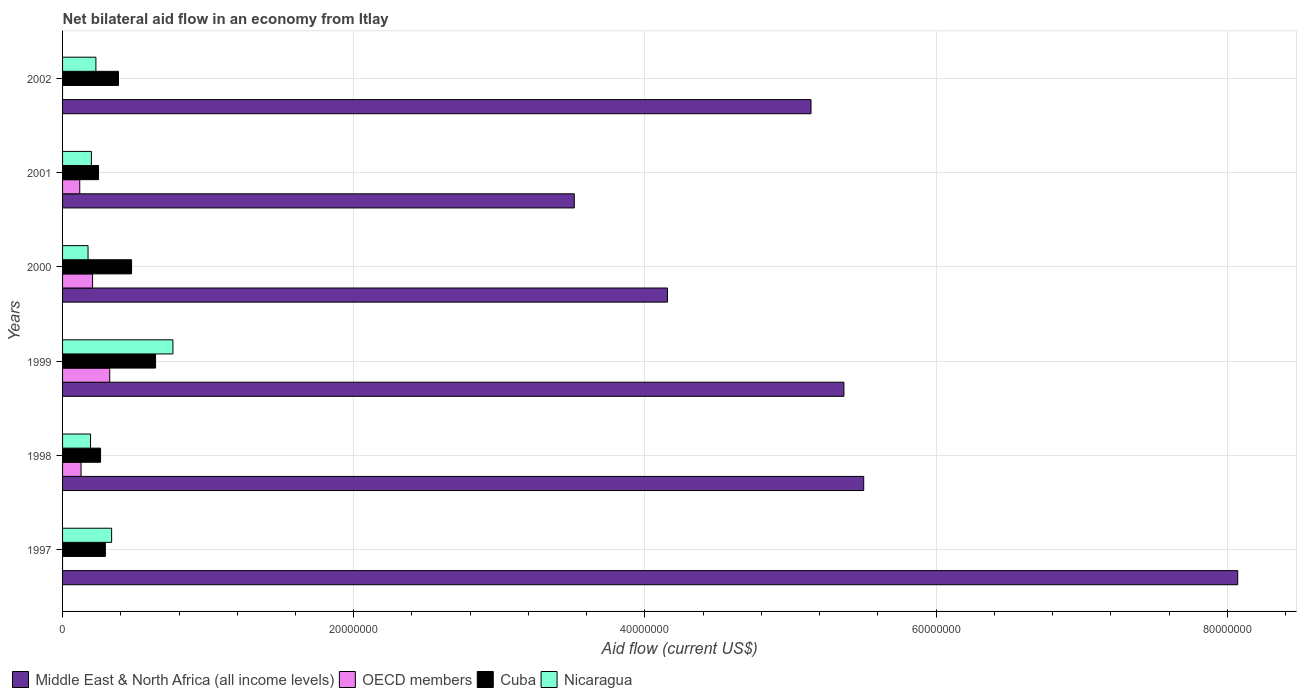How many different coloured bars are there?
Keep it short and to the point. 4. How many groups of bars are there?
Offer a terse response. 6. Are the number of bars per tick equal to the number of legend labels?
Provide a succinct answer. No. How many bars are there on the 2nd tick from the top?
Offer a very short reply. 4. How many bars are there on the 3rd tick from the bottom?
Keep it short and to the point. 4. What is the label of the 5th group of bars from the top?
Offer a terse response. 1998. In how many cases, is the number of bars for a given year not equal to the number of legend labels?
Offer a very short reply. 2. What is the net bilateral aid flow in Cuba in 2000?
Make the answer very short. 4.74e+06. Across all years, what is the maximum net bilateral aid flow in Nicaragua?
Provide a short and direct response. 7.58e+06. Across all years, what is the minimum net bilateral aid flow in Nicaragua?
Provide a short and direct response. 1.75e+06. What is the total net bilateral aid flow in Cuba in the graph?
Your response must be concise. 2.30e+07. What is the difference between the net bilateral aid flow in Cuba in 2000 and that in 2002?
Offer a terse response. 9.00e+05. What is the difference between the net bilateral aid flow in Nicaragua in 1997 and the net bilateral aid flow in Middle East & North Africa (all income levels) in 1998?
Provide a succinct answer. -5.17e+07. What is the average net bilateral aid flow in OECD members per year?
Give a very brief answer. 1.29e+06. In the year 2002, what is the difference between the net bilateral aid flow in Nicaragua and net bilateral aid flow in Middle East & North Africa (all income levels)?
Offer a very short reply. -4.91e+07. In how many years, is the net bilateral aid flow in Nicaragua greater than 16000000 US$?
Provide a short and direct response. 0. What is the ratio of the net bilateral aid flow in Nicaragua in 1998 to that in 2000?
Provide a succinct answer. 1.1. Is the net bilateral aid flow in OECD members in 2000 less than that in 2001?
Your answer should be compact. No. Is the difference between the net bilateral aid flow in Nicaragua in 1998 and 2002 greater than the difference between the net bilateral aid flow in Middle East & North Africa (all income levels) in 1998 and 2002?
Your response must be concise. No. What is the difference between the highest and the second highest net bilateral aid flow in Nicaragua?
Provide a short and direct response. 4.21e+06. What is the difference between the highest and the lowest net bilateral aid flow in Nicaragua?
Your answer should be very brief. 5.83e+06. In how many years, is the net bilateral aid flow in Nicaragua greater than the average net bilateral aid flow in Nicaragua taken over all years?
Your answer should be compact. 2. Is the sum of the net bilateral aid flow in OECD members in 1998 and 2000 greater than the maximum net bilateral aid flow in Cuba across all years?
Offer a terse response. No. Is it the case that in every year, the sum of the net bilateral aid flow in OECD members and net bilateral aid flow in Middle East & North Africa (all income levels) is greater than the sum of net bilateral aid flow in Nicaragua and net bilateral aid flow in Cuba?
Offer a very short reply. No. Is it the case that in every year, the sum of the net bilateral aid flow in OECD members and net bilateral aid flow in Nicaragua is greater than the net bilateral aid flow in Middle East & North Africa (all income levels)?
Your response must be concise. No. How many bars are there?
Ensure brevity in your answer.  22. What is the difference between two consecutive major ticks on the X-axis?
Your response must be concise. 2.00e+07. Are the values on the major ticks of X-axis written in scientific E-notation?
Provide a short and direct response. No. Does the graph contain any zero values?
Provide a short and direct response. Yes. Where does the legend appear in the graph?
Offer a very short reply. Bottom left. How many legend labels are there?
Offer a terse response. 4. What is the title of the graph?
Your response must be concise. Net bilateral aid flow in an economy from Itlay. Does "Iran" appear as one of the legend labels in the graph?
Offer a very short reply. No. What is the label or title of the Y-axis?
Provide a succinct answer. Years. What is the Aid flow (current US$) in Middle East & North Africa (all income levels) in 1997?
Make the answer very short. 8.07e+07. What is the Aid flow (current US$) of OECD members in 1997?
Offer a very short reply. 0. What is the Aid flow (current US$) in Cuba in 1997?
Give a very brief answer. 2.94e+06. What is the Aid flow (current US$) of Nicaragua in 1997?
Offer a terse response. 3.37e+06. What is the Aid flow (current US$) of Middle East & North Africa (all income levels) in 1998?
Make the answer very short. 5.50e+07. What is the Aid flow (current US$) of OECD members in 1998?
Provide a short and direct response. 1.27e+06. What is the Aid flow (current US$) in Cuba in 1998?
Your answer should be very brief. 2.61e+06. What is the Aid flow (current US$) in Nicaragua in 1998?
Ensure brevity in your answer.  1.92e+06. What is the Aid flow (current US$) of Middle East & North Africa (all income levels) in 1999?
Ensure brevity in your answer.  5.37e+07. What is the Aid flow (current US$) in OECD members in 1999?
Make the answer very short. 3.24e+06. What is the Aid flow (current US$) in Cuba in 1999?
Make the answer very short. 6.39e+06. What is the Aid flow (current US$) of Nicaragua in 1999?
Give a very brief answer. 7.58e+06. What is the Aid flow (current US$) of Middle East & North Africa (all income levels) in 2000?
Make the answer very short. 4.16e+07. What is the Aid flow (current US$) of OECD members in 2000?
Offer a very short reply. 2.06e+06. What is the Aid flow (current US$) in Cuba in 2000?
Your answer should be very brief. 4.74e+06. What is the Aid flow (current US$) in Nicaragua in 2000?
Offer a very short reply. 1.75e+06. What is the Aid flow (current US$) in Middle East & North Africa (all income levels) in 2001?
Offer a very short reply. 3.52e+07. What is the Aid flow (current US$) in OECD members in 2001?
Your answer should be very brief. 1.18e+06. What is the Aid flow (current US$) in Cuba in 2001?
Offer a terse response. 2.47e+06. What is the Aid flow (current US$) of Nicaragua in 2001?
Keep it short and to the point. 1.98e+06. What is the Aid flow (current US$) in Middle East & North Africa (all income levels) in 2002?
Provide a short and direct response. 5.14e+07. What is the Aid flow (current US$) of Cuba in 2002?
Ensure brevity in your answer.  3.84e+06. What is the Aid flow (current US$) in Nicaragua in 2002?
Ensure brevity in your answer.  2.29e+06. Across all years, what is the maximum Aid flow (current US$) of Middle East & North Africa (all income levels)?
Provide a succinct answer. 8.07e+07. Across all years, what is the maximum Aid flow (current US$) in OECD members?
Keep it short and to the point. 3.24e+06. Across all years, what is the maximum Aid flow (current US$) of Cuba?
Offer a terse response. 6.39e+06. Across all years, what is the maximum Aid flow (current US$) in Nicaragua?
Provide a short and direct response. 7.58e+06. Across all years, what is the minimum Aid flow (current US$) in Middle East & North Africa (all income levels)?
Provide a succinct answer. 3.52e+07. Across all years, what is the minimum Aid flow (current US$) of OECD members?
Provide a succinct answer. 0. Across all years, what is the minimum Aid flow (current US$) in Cuba?
Give a very brief answer. 2.47e+06. Across all years, what is the minimum Aid flow (current US$) in Nicaragua?
Keep it short and to the point. 1.75e+06. What is the total Aid flow (current US$) of Middle East & North Africa (all income levels) in the graph?
Provide a short and direct response. 3.18e+08. What is the total Aid flow (current US$) of OECD members in the graph?
Your response must be concise. 7.75e+06. What is the total Aid flow (current US$) in Cuba in the graph?
Your answer should be compact. 2.30e+07. What is the total Aid flow (current US$) in Nicaragua in the graph?
Offer a terse response. 1.89e+07. What is the difference between the Aid flow (current US$) of Middle East & North Africa (all income levels) in 1997 and that in 1998?
Ensure brevity in your answer.  2.57e+07. What is the difference between the Aid flow (current US$) in Cuba in 1997 and that in 1998?
Ensure brevity in your answer.  3.30e+05. What is the difference between the Aid flow (current US$) of Nicaragua in 1997 and that in 1998?
Offer a very short reply. 1.45e+06. What is the difference between the Aid flow (current US$) in Middle East & North Africa (all income levels) in 1997 and that in 1999?
Provide a short and direct response. 2.70e+07. What is the difference between the Aid flow (current US$) of Cuba in 1997 and that in 1999?
Your answer should be compact. -3.45e+06. What is the difference between the Aid flow (current US$) in Nicaragua in 1997 and that in 1999?
Provide a short and direct response. -4.21e+06. What is the difference between the Aid flow (current US$) of Middle East & North Africa (all income levels) in 1997 and that in 2000?
Give a very brief answer. 3.92e+07. What is the difference between the Aid flow (current US$) of Cuba in 1997 and that in 2000?
Your answer should be very brief. -1.80e+06. What is the difference between the Aid flow (current US$) in Nicaragua in 1997 and that in 2000?
Provide a short and direct response. 1.62e+06. What is the difference between the Aid flow (current US$) in Middle East & North Africa (all income levels) in 1997 and that in 2001?
Ensure brevity in your answer.  4.56e+07. What is the difference between the Aid flow (current US$) of Nicaragua in 1997 and that in 2001?
Give a very brief answer. 1.39e+06. What is the difference between the Aid flow (current US$) in Middle East & North Africa (all income levels) in 1997 and that in 2002?
Ensure brevity in your answer.  2.93e+07. What is the difference between the Aid flow (current US$) of Cuba in 1997 and that in 2002?
Offer a very short reply. -9.00e+05. What is the difference between the Aid flow (current US$) in Nicaragua in 1997 and that in 2002?
Your answer should be very brief. 1.08e+06. What is the difference between the Aid flow (current US$) in Middle East & North Africa (all income levels) in 1998 and that in 1999?
Keep it short and to the point. 1.36e+06. What is the difference between the Aid flow (current US$) in OECD members in 1998 and that in 1999?
Offer a terse response. -1.97e+06. What is the difference between the Aid flow (current US$) in Cuba in 1998 and that in 1999?
Make the answer very short. -3.78e+06. What is the difference between the Aid flow (current US$) in Nicaragua in 1998 and that in 1999?
Your response must be concise. -5.66e+06. What is the difference between the Aid flow (current US$) in Middle East & North Africa (all income levels) in 1998 and that in 2000?
Provide a succinct answer. 1.35e+07. What is the difference between the Aid flow (current US$) in OECD members in 1998 and that in 2000?
Provide a short and direct response. -7.90e+05. What is the difference between the Aid flow (current US$) in Cuba in 1998 and that in 2000?
Give a very brief answer. -2.13e+06. What is the difference between the Aid flow (current US$) in Middle East & North Africa (all income levels) in 1998 and that in 2001?
Make the answer very short. 1.99e+07. What is the difference between the Aid flow (current US$) of OECD members in 1998 and that in 2001?
Keep it short and to the point. 9.00e+04. What is the difference between the Aid flow (current US$) in Cuba in 1998 and that in 2001?
Make the answer very short. 1.40e+05. What is the difference between the Aid flow (current US$) in Middle East & North Africa (all income levels) in 1998 and that in 2002?
Provide a succinct answer. 3.62e+06. What is the difference between the Aid flow (current US$) in Cuba in 1998 and that in 2002?
Your answer should be very brief. -1.23e+06. What is the difference between the Aid flow (current US$) of Nicaragua in 1998 and that in 2002?
Make the answer very short. -3.70e+05. What is the difference between the Aid flow (current US$) of Middle East & North Africa (all income levels) in 1999 and that in 2000?
Provide a short and direct response. 1.21e+07. What is the difference between the Aid flow (current US$) in OECD members in 1999 and that in 2000?
Offer a very short reply. 1.18e+06. What is the difference between the Aid flow (current US$) in Cuba in 1999 and that in 2000?
Your answer should be very brief. 1.65e+06. What is the difference between the Aid flow (current US$) of Nicaragua in 1999 and that in 2000?
Your response must be concise. 5.83e+06. What is the difference between the Aid flow (current US$) in Middle East & North Africa (all income levels) in 1999 and that in 2001?
Your response must be concise. 1.85e+07. What is the difference between the Aid flow (current US$) of OECD members in 1999 and that in 2001?
Keep it short and to the point. 2.06e+06. What is the difference between the Aid flow (current US$) in Cuba in 1999 and that in 2001?
Your response must be concise. 3.92e+06. What is the difference between the Aid flow (current US$) in Nicaragua in 1999 and that in 2001?
Make the answer very short. 5.60e+06. What is the difference between the Aid flow (current US$) of Middle East & North Africa (all income levels) in 1999 and that in 2002?
Make the answer very short. 2.26e+06. What is the difference between the Aid flow (current US$) of Cuba in 1999 and that in 2002?
Your answer should be very brief. 2.55e+06. What is the difference between the Aid flow (current US$) in Nicaragua in 1999 and that in 2002?
Your response must be concise. 5.29e+06. What is the difference between the Aid flow (current US$) in Middle East & North Africa (all income levels) in 2000 and that in 2001?
Ensure brevity in your answer.  6.40e+06. What is the difference between the Aid flow (current US$) of OECD members in 2000 and that in 2001?
Provide a short and direct response. 8.80e+05. What is the difference between the Aid flow (current US$) in Cuba in 2000 and that in 2001?
Make the answer very short. 2.27e+06. What is the difference between the Aid flow (current US$) in Nicaragua in 2000 and that in 2001?
Make the answer very short. -2.30e+05. What is the difference between the Aid flow (current US$) of Middle East & North Africa (all income levels) in 2000 and that in 2002?
Your answer should be compact. -9.86e+06. What is the difference between the Aid flow (current US$) in Cuba in 2000 and that in 2002?
Your answer should be very brief. 9.00e+05. What is the difference between the Aid flow (current US$) of Nicaragua in 2000 and that in 2002?
Offer a terse response. -5.40e+05. What is the difference between the Aid flow (current US$) of Middle East & North Africa (all income levels) in 2001 and that in 2002?
Ensure brevity in your answer.  -1.63e+07. What is the difference between the Aid flow (current US$) in Cuba in 2001 and that in 2002?
Give a very brief answer. -1.37e+06. What is the difference between the Aid flow (current US$) in Nicaragua in 2001 and that in 2002?
Give a very brief answer. -3.10e+05. What is the difference between the Aid flow (current US$) in Middle East & North Africa (all income levels) in 1997 and the Aid flow (current US$) in OECD members in 1998?
Make the answer very short. 7.94e+07. What is the difference between the Aid flow (current US$) in Middle East & North Africa (all income levels) in 1997 and the Aid flow (current US$) in Cuba in 1998?
Your response must be concise. 7.81e+07. What is the difference between the Aid flow (current US$) in Middle East & North Africa (all income levels) in 1997 and the Aid flow (current US$) in Nicaragua in 1998?
Ensure brevity in your answer.  7.88e+07. What is the difference between the Aid flow (current US$) in Cuba in 1997 and the Aid flow (current US$) in Nicaragua in 1998?
Your answer should be compact. 1.02e+06. What is the difference between the Aid flow (current US$) of Middle East & North Africa (all income levels) in 1997 and the Aid flow (current US$) of OECD members in 1999?
Offer a very short reply. 7.75e+07. What is the difference between the Aid flow (current US$) in Middle East & North Africa (all income levels) in 1997 and the Aid flow (current US$) in Cuba in 1999?
Your answer should be compact. 7.43e+07. What is the difference between the Aid flow (current US$) in Middle East & North Africa (all income levels) in 1997 and the Aid flow (current US$) in Nicaragua in 1999?
Keep it short and to the point. 7.31e+07. What is the difference between the Aid flow (current US$) of Cuba in 1997 and the Aid flow (current US$) of Nicaragua in 1999?
Make the answer very short. -4.64e+06. What is the difference between the Aid flow (current US$) of Middle East & North Africa (all income levels) in 1997 and the Aid flow (current US$) of OECD members in 2000?
Provide a succinct answer. 7.87e+07. What is the difference between the Aid flow (current US$) in Middle East & North Africa (all income levels) in 1997 and the Aid flow (current US$) in Cuba in 2000?
Keep it short and to the point. 7.60e+07. What is the difference between the Aid flow (current US$) of Middle East & North Africa (all income levels) in 1997 and the Aid flow (current US$) of Nicaragua in 2000?
Give a very brief answer. 7.90e+07. What is the difference between the Aid flow (current US$) of Cuba in 1997 and the Aid flow (current US$) of Nicaragua in 2000?
Your answer should be compact. 1.19e+06. What is the difference between the Aid flow (current US$) of Middle East & North Africa (all income levels) in 1997 and the Aid flow (current US$) of OECD members in 2001?
Provide a short and direct response. 7.95e+07. What is the difference between the Aid flow (current US$) in Middle East & North Africa (all income levels) in 1997 and the Aid flow (current US$) in Cuba in 2001?
Offer a very short reply. 7.82e+07. What is the difference between the Aid flow (current US$) of Middle East & North Africa (all income levels) in 1997 and the Aid flow (current US$) of Nicaragua in 2001?
Offer a very short reply. 7.87e+07. What is the difference between the Aid flow (current US$) in Cuba in 1997 and the Aid flow (current US$) in Nicaragua in 2001?
Your answer should be very brief. 9.60e+05. What is the difference between the Aid flow (current US$) of Middle East & North Africa (all income levels) in 1997 and the Aid flow (current US$) of Cuba in 2002?
Offer a very short reply. 7.69e+07. What is the difference between the Aid flow (current US$) in Middle East & North Africa (all income levels) in 1997 and the Aid flow (current US$) in Nicaragua in 2002?
Provide a short and direct response. 7.84e+07. What is the difference between the Aid flow (current US$) in Cuba in 1997 and the Aid flow (current US$) in Nicaragua in 2002?
Your answer should be compact. 6.50e+05. What is the difference between the Aid flow (current US$) in Middle East & North Africa (all income levels) in 1998 and the Aid flow (current US$) in OECD members in 1999?
Offer a terse response. 5.18e+07. What is the difference between the Aid flow (current US$) in Middle East & North Africa (all income levels) in 1998 and the Aid flow (current US$) in Cuba in 1999?
Offer a terse response. 4.86e+07. What is the difference between the Aid flow (current US$) of Middle East & North Africa (all income levels) in 1998 and the Aid flow (current US$) of Nicaragua in 1999?
Give a very brief answer. 4.74e+07. What is the difference between the Aid flow (current US$) in OECD members in 1998 and the Aid flow (current US$) in Cuba in 1999?
Provide a succinct answer. -5.12e+06. What is the difference between the Aid flow (current US$) in OECD members in 1998 and the Aid flow (current US$) in Nicaragua in 1999?
Provide a short and direct response. -6.31e+06. What is the difference between the Aid flow (current US$) of Cuba in 1998 and the Aid flow (current US$) of Nicaragua in 1999?
Ensure brevity in your answer.  -4.97e+06. What is the difference between the Aid flow (current US$) of Middle East & North Africa (all income levels) in 1998 and the Aid flow (current US$) of OECD members in 2000?
Provide a short and direct response. 5.30e+07. What is the difference between the Aid flow (current US$) in Middle East & North Africa (all income levels) in 1998 and the Aid flow (current US$) in Cuba in 2000?
Offer a terse response. 5.03e+07. What is the difference between the Aid flow (current US$) of Middle East & North Africa (all income levels) in 1998 and the Aid flow (current US$) of Nicaragua in 2000?
Offer a very short reply. 5.33e+07. What is the difference between the Aid flow (current US$) in OECD members in 1998 and the Aid flow (current US$) in Cuba in 2000?
Give a very brief answer. -3.47e+06. What is the difference between the Aid flow (current US$) of OECD members in 1998 and the Aid flow (current US$) of Nicaragua in 2000?
Your answer should be compact. -4.80e+05. What is the difference between the Aid flow (current US$) of Cuba in 1998 and the Aid flow (current US$) of Nicaragua in 2000?
Your response must be concise. 8.60e+05. What is the difference between the Aid flow (current US$) of Middle East & North Africa (all income levels) in 1998 and the Aid flow (current US$) of OECD members in 2001?
Your answer should be very brief. 5.38e+07. What is the difference between the Aid flow (current US$) of Middle East & North Africa (all income levels) in 1998 and the Aid flow (current US$) of Cuba in 2001?
Offer a terse response. 5.26e+07. What is the difference between the Aid flow (current US$) in Middle East & North Africa (all income levels) in 1998 and the Aid flow (current US$) in Nicaragua in 2001?
Give a very brief answer. 5.30e+07. What is the difference between the Aid flow (current US$) of OECD members in 1998 and the Aid flow (current US$) of Cuba in 2001?
Your answer should be very brief. -1.20e+06. What is the difference between the Aid flow (current US$) in OECD members in 1998 and the Aid flow (current US$) in Nicaragua in 2001?
Make the answer very short. -7.10e+05. What is the difference between the Aid flow (current US$) of Cuba in 1998 and the Aid flow (current US$) of Nicaragua in 2001?
Make the answer very short. 6.30e+05. What is the difference between the Aid flow (current US$) in Middle East & North Africa (all income levels) in 1998 and the Aid flow (current US$) in Cuba in 2002?
Make the answer very short. 5.12e+07. What is the difference between the Aid flow (current US$) in Middle East & North Africa (all income levels) in 1998 and the Aid flow (current US$) in Nicaragua in 2002?
Give a very brief answer. 5.27e+07. What is the difference between the Aid flow (current US$) in OECD members in 1998 and the Aid flow (current US$) in Cuba in 2002?
Your answer should be compact. -2.57e+06. What is the difference between the Aid flow (current US$) of OECD members in 1998 and the Aid flow (current US$) of Nicaragua in 2002?
Offer a very short reply. -1.02e+06. What is the difference between the Aid flow (current US$) in Middle East & North Africa (all income levels) in 1999 and the Aid flow (current US$) in OECD members in 2000?
Offer a very short reply. 5.16e+07. What is the difference between the Aid flow (current US$) of Middle East & North Africa (all income levels) in 1999 and the Aid flow (current US$) of Cuba in 2000?
Give a very brief answer. 4.89e+07. What is the difference between the Aid flow (current US$) of Middle East & North Africa (all income levels) in 1999 and the Aid flow (current US$) of Nicaragua in 2000?
Provide a succinct answer. 5.19e+07. What is the difference between the Aid flow (current US$) in OECD members in 1999 and the Aid flow (current US$) in Cuba in 2000?
Ensure brevity in your answer.  -1.50e+06. What is the difference between the Aid flow (current US$) in OECD members in 1999 and the Aid flow (current US$) in Nicaragua in 2000?
Make the answer very short. 1.49e+06. What is the difference between the Aid flow (current US$) of Cuba in 1999 and the Aid flow (current US$) of Nicaragua in 2000?
Provide a short and direct response. 4.64e+06. What is the difference between the Aid flow (current US$) of Middle East & North Africa (all income levels) in 1999 and the Aid flow (current US$) of OECD members in 2001?
Offer a terse response. 5.25e+07. What is the difference between the Aid flow (current US$) of Middle East & North Africa (all income levels) in 1999 and the Aid flow (current US$) of Cuba in 2001?
Offer a terse response. 5.12e+07. What is the difference between the Aid flow (current US$) of Middle East & North Africa (all income levels) in 1999 and the Aid flow (current US$) of Nicaragua in 2001?
Ensure brevity in your answer.  5.17e+07. What is the difference between the Aid flow (current US$) of OECD members in 1999 and the Aid flow (current US$) of Cuba in 2001?
Ensure brevity in your answer.  7.70e+05. What is the difference between the Aid flow (current US$) of OECD members in 1999 and the Aid flow (current US$) of Nicaragua in 2001?
Your answer should be compact. 1.26e+06. What is the difference between the Aid flow (current US$) in Cuba in 1999 and the Aid flow (current US$) in Nicaragua in 2001?
Your answer should be compact. 4.41e+06. What is the difference between the Aid flow (current US$) of Middle East & North Africa (all income levels) in 1999 and the Aid flow (current US$) of Cuba in 2002?
Offer a very short reply. 4.98e+07. What is the difference between the Aid flow (current US$) of Middle East & North Africa (all income levels) in 1999 and the Aid flow (current US$) of Nicaragua in 2002?
Provide a short and direct response. 5.14e+07. What is the difference between the Aid flow (current US$) in OECD members in 1999 and the Aid flow (current US$) in Cuba in 2002?
Provide a succinct answer. -6.00e+05. What is the difference between the Aid flow (current US$) in OECD members in 1999 and the Aid flow (current US$) in Nicaragua in 2002?
Your answer should be very brief. 9.50e+05. What is the difference between the Aid flow (current US$) in Cuba in 1999 and the Aid flow (current US$) in Nicaragua in 2002?
Offer a very short reply. 4.10e+06. What is the difference between the Aid flow (current US$) of Middle East & North Africa (all income levels) in 2000 and the Aid flow (current US$) of OECD members in 2001?
Your response must be concise. 4.04e+07. What is the difference between the Aid flow (current US$) of Middle East & North Africa (all income levels) in 2000 and the Aid flow (current US$) of Cuba in 2001?
Give a very brief answer. 3.91e+07. What is the difference between the Aid flow (current US$) in Middle East & North Africa (all income levels) in 2000 and the Aid flow (current US$) in Nicaragua in 2001?
Your answer should be compact. 3.96e+07. What is the difference between the Aid flow (current US$) of OECD members in 2000 and the Aid flow (current US$) of Cuba in 2001?
Ensure brevity in your answer.  -4.10e+05. What is the difference between the Aid flow (current US$) in Cuba in 2000 and the Aid flow (current US$) in Nicaragua in 2001?
Your answer should be compact. 2.76e+06. What is the difference between the Aid flow (current US$) in Middle East & North Africa (all income levels) in 2000 and the Aid flow (current US$) in Cuba in 2002?
Provide a short and direct response. 3.77e+07. What is the difference between the Aid flow (current US$) of Middle East & North Africa (all income levels) in 2000 and the Aid flow (current US$) of Nicaragua in 2002?
Your answer should be very brief. 3.93e+07. What is the difference between the Aid flow (current US$) of OECD members in 2000 and the Aid flow (current US$) of Cuba in 2002?
Make the answer very short. -1.78e+06. What is the difference between the Aid flow (current US$) of OECD members in 2000 and the Aid flow (current US$) of Nicaragua in 2002?
Your answer should be compact. -2.30e+05. What is the difference between the Aid flow (current US$) of Cuba in 2000 and the Aid flow (current US$) of Nicaragua in 2002?
Provide a succinct answer. 2.45e+06. What is the difference between the Aid flow (current US$) in Middle East & North Africa (all income levels) in 2001 and the Aid flow (current US$) in Cuba in 2002?
Your answer should be very brief. 3.13e+07. What is the difference between the Aid flow (current US$) of Middle East & North Africa (all income levels) in 2001 and the Aid flow (current US$) of Nicaragua in 2002?
Offer a very short reply. 3.29e+07. What is the difference between the Aid flow (current US$) in OECD members in 2001 and the Aid flow (current US$) in Cuba in 2002?
Offer a terse response. -2.66e+06. What is the difference between the Aid flow (current US$) of OECD members in 2001 and the Aid flow (current US$) of Nicaragua in 2002?
Make the answer very short. -1.11e+06. What is the average Aid flow (current US$) of Middle East & North Africa (all income levels) per year?
Keep it short and to the point. 5.29e+07. What is the average Aid flow (current US$) of OECD members per year?
Offer a very short reply. 1.29e+06. What is the average Aid flow (current US$) in Cuba per year?
Keep it short and to the point. 3.83e+06. What is the average Aid flow (current US$) of Nicaragua per year?
Offer a very short reply. 3.15e+06. In the year 1997, what is the difference between the Aid flow (current US$) of Middle East & North Africa (all income levels) and Aid flow (current US$) of Cuba?
Give a very brief answer. 7.78e+07. In the year 1997, what is the difference between the Aid flow (current US$) in Middle East & North Africa (all income levels) and Aid flow (current US$) in Nicaragua?
Ensure brevity in your answer.  7.74e+07. In the year 1997, what is the difference between the Aid flow (current US$) in Cuba and Aid flow (current US$) in Nicaragua?
Offer a terse response. -4.30e+05. In the year 1998, what is the difference between the Aid flow (current US$) of Middle East & North Africa (all income levels) and Aid flow (current US$) of OECD members?
Offer a very short reply. 5.38e+07. In the year 1998, what is the difference between the Aid flow (current US$) of Middle East & North Africa (all income levels) and Aid flow (current US$) of Cuba?
Provide a short and direct response. 5.24e+07. In the year 1998, what is the difference between the Aid flow (current US$) of Middle East & North Africa (all income levels) and Aid flow (current US$) of Nicaragua?
Offer a terse response. 5.31e+07. In the year 1998, what is the difference between the Aid flow (current US$) of OECD members and Aid flow (current US$) of Cuba?
Make the answer very short. -1.34e+06. In the year 1998, what is the difference between the Aid flow (current US$) of OECD members and Aid flow (current US$) of Nicaragua?
Your answer should be compact. -6.50e+05. In the year 1998, what is the difference between the Aid flow (current US$) of Cuba and Aid flow (current US$) of Nicaragua?
Your answer should be very brief. 6.90e+05. In the year 1999, what is the difference between the Aid flow (current US$) of Middle East & North Africa (all income levels) and Aid flow (current US$) of OECD members?
Make the answer very short. 5.04e+07. In the year 1999, what is the difference between the Aid flow (current US$) of Middle East & North Africa (all income levels) and Aid flow (current US$) of Cuba?
Your answer should be compact. 4.73e+07. In the year 1999, what is the difference between the Aid flow (current US$) in Middle East & North Africa (all income levels) and Aid flow (current US$) in Nicaragua?
Give a very brief answer. 4.61e+07. In the year 1999, what is the difference between the Aid flow (current US$) in OECD members and Aid flow (current US$) in Cuba?
Ensure brevity in your answer.  -3.15e+06. In the year 1999, what is the difference between the Aid flow (current US$) in OECD members and Aid flow (current US$) in Nicaragua?
Ensure brevity in your answer.  -4.34e+06. In the year 1999, what is the difference between the Aid flow (current US$) of Cuba and Aid flow (current US$) of Nicaragua?
Give a very brief answer. -1.19e+06. In the year 2000, what is the difference between the Aid flow (current US$) in Middle East & North Africa (all income levels) and Aid flow (current US$) in OECD members?
Offer a terse response. 3.95e+07. In the year 2000, what is the difference between the Aid flow (current US$) in Middle East & North Africa (all income levels) and Aid flow (current US$) in Cuba?
Your response must be concise. 3.68e+07. In the year 2000, what is the difference between the Aid flow (current US$) in Middle East & North Africa (all income levels) and Aid flow (current US$) in Nicaragua?
Your answer should be very brief. 3.98e+07. In the year 2000, what is the difference between the Aid flow (current US$) in OECD members and Aid flow (current US$) in Cuba?
Offer a terse response. -2.68e+06. In the year 2000, what is the difference between the Aid flow (current US$) in OECD members and Aid flow (current US$) in Nicaragua?
Give a very brief answer. 3.10e+05. In the year 2000, what is the difference between the Aid flow (current US$) of Cuba and Aid flow (current US$) of Nicaragua?
Keep it short and to the point. 2.99e+06. In the year 2001, what is the difference between the Aid flow (current US$) of Middle East & North Africa (all income levels) and Aid flow (current US$) of OECD members?
Your answer should be compact. 3.40e+07. In the year 2001, what is the difference between the Aid flow (current US$) of Middle East & North Africa (all income levels) and Aid flow (current US$) of Cuba?
Keep it short and to the point. 3.27e+07. In the year 2001, what is the difference between the Aid flow (current US$) in Middle East & North Africa (all income levels) and Aid flow (current US$) in Nicaragua?
Provide a short and direct response. 3.32e+07. In the year 2001, what is the difference between the Aid flow (current US$) of OECD members and Aid flow (current US$) of Cuba?
Offer a terse response. -1.29e+06. In the year 2001, what is the difference between the Aid flow (current US$) of OECD members and Aid flow (current US$) of Nicaragua?
Ensure brevity in your answer.  -8.00e+05. In the year 2001, what is the difference between the Aid flow (current US$) in Cuba and Aid flow (current US$) in Nicaragua?
Your answer should be very brief. 4.90e+05. In the year 2002, what is the difference between the Aid flow (current US$) of Middle East & North Africa (all income levels) and Aid flow (current US$) of Cuba?
Provide a succinct answer. 4.76e+07. In the year 2002, what is the difference between the Aid flow (current US$) in Middle East & North Africa (all income levels) and Aid flow (current US$) in Nicaragua?
Your response must be concise. 4.91e+07. In the year 2002, what is the difference between the Aid flow (current US$) in Cuba and Aid flow (current US$) in Nicaragua?
Offer a very short reply. 1.55e+06. What is the ratio of the Aid flow (current US$) in Middle East & North Africa (all income levels) in 1997 to that in 1998?
Your answer should be very brief. 1.47. What is the ratio of the Aid flow (current US$) in Cuba in 1997 to that in 1998?
Offer a terse response. 1.13. What is the ratio of the Aid flow (current US$) in Nicaragua in 1997 to that in 1998?
Offer a terse response. 1.76. What is the ratio of the Aid flow (current US$) of Middle East & North Africa (all income levels) in 1997 to that in 1999?
Make the answer very short. 1.5. What is the ratio of the Aid flow (current US$) in Cuba in 1997 to that in 1999?
Give a very brief answer. 0.46. What is the ratio of the Aid flow (current US$) in Nicaragua in 1997 to that in 1999?
Your answer should be very brief. 0.44. What is the ratio of the Aid flow (current US$) in Middle East & North Africa (all income levels) in 1997 to that in 2000?
Give a very brief answer. 1.94. What is the ratio of the Aid flow (current US$) in Cuba in 1997 to that in 2000?
Offer a terse response. 0.62. What is the ratio of the Aid flow (current US$) of Nicaragua in 1997 to that in 2000?
Give a very brief answer. 1.93. What is the ratio of the Aid flow (current US$) of Middle East & North Africa (all income levels) in 1997 to that in 2001?
Ensure brevity in your answer.  2.3. What is the ratio of the Aid flow (current US$) of Cuba in 1997 to that in 2001?
Keep it short and to the point. 1.19. What is the ratio of the Aid flow (current US$) in Nicaragua in 1997 to that in 2001?
Offer a terse response. 1.7. What is the ratio of the Aid flow (current US$) in Middle East & North Africa (all income levels) in 1997 to that in 2002?
Provide a short and direct response. 1.57. What is the ratio of the Aid flow (current US$) in Cuba in 1997 to that in 2002?
Your answer should be compact. 0.77. What is the ratio of the Aid flow (current US$) of Nicaragua in 1997 to that in 2002?
Your answer should be compact. 1.47. What is the ratio of the Aid flow (current US$) of Middle East & North Africa (all income levels) in 1998 to that in 1999?
Make the answer very short. 1.03. What is the ratio of the Aid flow (current US$) of OECD members in 1998 to that in 1999?
Your answer should be compact. 0.39. What is the ratio of the Aid flow (current US$) in Cuba in 1998 to that in 1999?
Give a very brief answer. 0.41. What is the ratio of the Aid flow (current US$) in Nicaragua in 1998 to that in 1999?
Give a very brief answer. 0.25. What is the ratio of the Aid flow (current US$) of Middle East & North Africa (all income levels) in 1998 to that in 2000?
Provide a short and direct response. 1.32. What is the ratio of the Aid flow (current US$) in OECD members in 1998 to that in 2000?
Offer a terse response. 0.62. What is the ratio of the Aid flow (current US$) in Cuba in 1998 to that in 2000?
Your answer should be very brief. 0.55. What is the ratio of the Aid flow (current US$) of Nicaragua in 1998 to that in 2000?
Ensure brevity in your answer.  1.1. What is the ratio of the Aid flow (current US$) in Middle East & North Africa (all income levels) in 1998 to that in 2001?
Your response must be concise. 1.57. What is the ratio of the Aid flow (current US$) in OECD members in 1998 to that in 2001?
Your response must be concise. 1.08. What is the ratio of the Aid flow (current US$) in Cuba in 1998 to that in 2001?
Provide a succinct answer. 1.06. What is the ratio of the Aid flow (current US$) in Nicaragua in 1998 to that in 2001?
Your answer should be compact. 0.97. What is the ratio of the Aid flow (current US$) in Middle East & North Africa (all income levels) in 1998 to that in 2002?
Give a very brief answer. 1.07. What is the ratio of the Aid flow (current US$) in Cuba in 1998 to that in 2002?
Ensure brevity in your answer.  0.68. What is the ratio of the Aid flow (current US$) of Nicaragua in 1998 to that in 2002?
Offer a terse response. 0.84. What is the ratio of the Aid flow (current US$) in Middle East & North Africa (all income levels) in 1999 to that in 2000?
Keep it short and to the point. 1.29. What is the ratio of the Aid flow (current US$) in OECD members in 1999 to that in 2000?
Offer a terse response. 1.57. What is the ratio of the Aid flow (current US$) of Cuba in 1999 to that in 2000?
Make the answer very short. 1.35. What is the ratio of the Aid flow (current US$) of Nicaragua in 1999 to that in 2000?
Ensure brevity in your answer.  4.33. What is the ratio of the Aid flow (current US$) of Middle East & North Africa (all income levels) in 1999 to that in 2001?
Provide a succinct answer. 1.53. What is the ratio of the Aid flow (current US$) in OECD members in 1999 to that in 2001?
Your answer should be compact. 2.75. What is the ratio of the Aid flow (current US$) in Cuba in 1999 to that in 2001?
Make the answer very short. 2.59. What is the ratio of the Aid flow (current US$) of Nicaragua in 1999 to that in 2001?
Offer a terse response. 3.83. What is the ratio of the Aid flow (current US$) of Middle East & North Africa (all income levels) in 1999 to that in 2002?
Your answer should be very brief. 1.04. What is the ratio of the Aid flow (current US$) in Cuba in 1999 to that in 2002?
Make the answer very short. 1.66. What is the ratio of the Aid flow (current US$) in Nicaragua in 1999 to that in 2002?
Your response must be concise. 3.31. What is the ratio of the Aid flow (current US$) of Middle East & North Africa (all income levels) in 2000 to that in 2001?
Provide a short and direct response. 1.18. What is the ratio of the Aid flow (current US$) of OECD members in 2000 to that in 2001?
Give a very brief answer. 1.75. What is the ratio of the Aid flow (current US$) of Cuba in 2000 to that in 2001?
Your response must be concise. 1.92. What is the ratio of the Aid flow (current US$) of Nicaragua in 2000 to that in 2001?
Provide a short and direct response. 0.88. What is the ratio of the Aid flow (current US$) in Middle East & North Africa (all income levels) in 2000 to that in 2002?
Your response must be concise. 0.81. What is the ratio of the Aid flow (current US$) in Cuba in 2000 to that in 2002?
Provide a short and direct response. 1.23. What is the ratio of the Aid flow (current US$) in Nicaragua in 2000 to that in 2002?
Provide a succinct answer. 0.76. What is the ratio of the Aid flow (current US$) of Middle East & North Africa (all income levels) in 2001 to that in 2002?
Make the answer very short. 0.68. What is the ratio of the Aid flow (current US$) of Cuba in 2001 to that in 2002?
Offer a very short reply. 0.64. What is the ratio of the Aid flow (current US$) in Nicaragua in 2001 to that in 2002?
Your answer should be compact. 0.86. What is the difference between the highest and the second highest Aid flow (current US$) of Middle East & North Africa (all income levels)?
Make the answer very short. 2.57e+07. What is the difference between the highest and the second highest Aid flow (current US$) of OECD members?
Offer a terse response. 1.18e+06. What is the difference between the highest and the second highest Aid flow (current US$) of Cuba?
Make the answer very short. 1.65e+06. What is the difference between the highest and the second highest Aid flow (current US$) of Nicaragua?
Make the answer very short. 4.21e+06. What is the difference between the highest and the lowest Aid flow (current US$) in Middle East & North Africa (all income levels)?
Offer a very short reply. 4.56e+07. What is the difference between the highest and the lowest Aid flow (current US$) in OECD members?
Ensure brevity in your answer.  3.24e+06. What is the difference between the highest and the lowest Aid flow (current US$) in Cuba?
Offer a terse response. 3.92e+06. What is the difference between the highest and the lowest Aid flow (current US$) of Nicaragua?
Provide a succinct answer. 5.83e+06. 